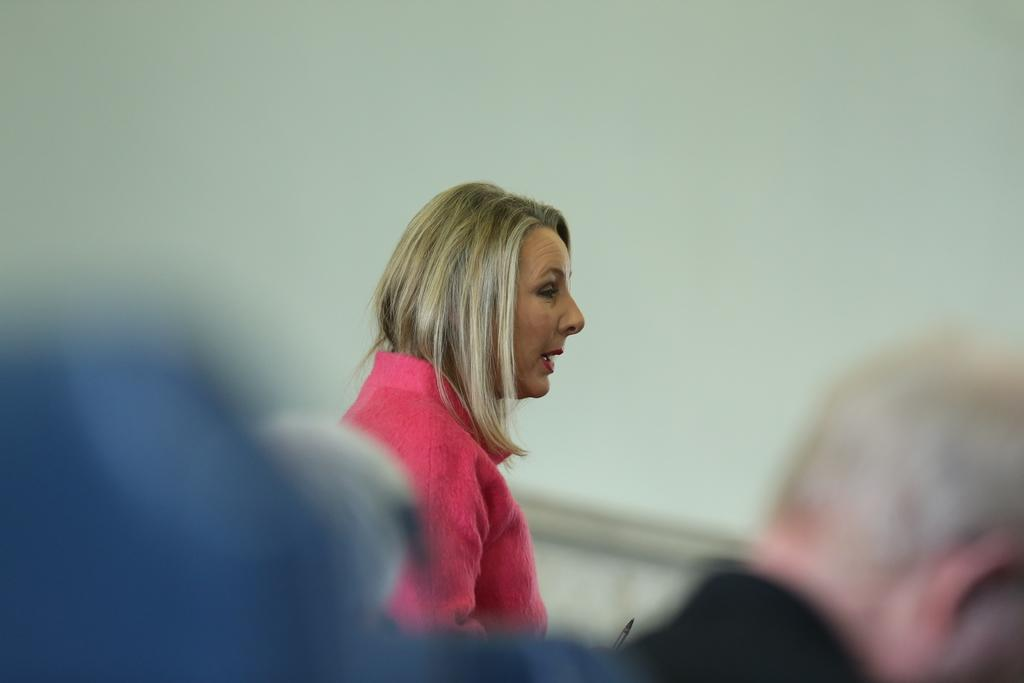How many individuals are present in the image? There are two people in the image. What is located behind the people in the image? There is a wall behind the people. What type of finger can be seen holding the thing in the image? There is no finger or thing present in the image. 